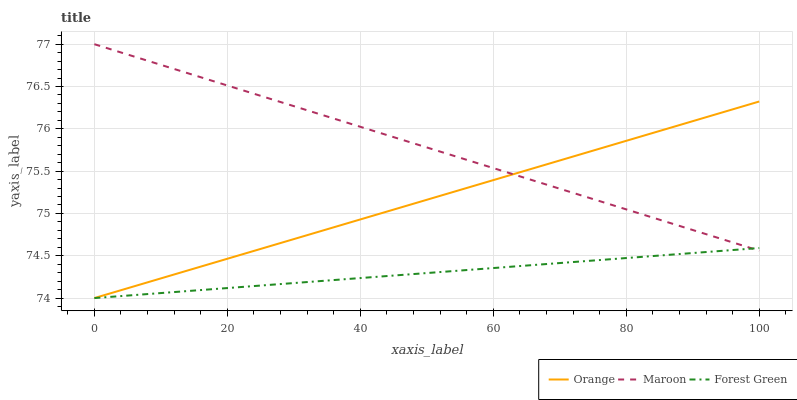Does Forest Green have the minimum area under the curve?
Answer yes or no. Yes. Does Maroon have the maximum area under the curve?
Answer yes or no. Yes. Does Maroon have the minimum area under the curve?
Answer yes or no. No. Does Forest Green have the maximum area under the curve?
Answer yes or no. No. Is Forest Green the smoothest?
Answer yes or no. Yes. Is Orange the roughest?
Answer yes or no. Yes. Is Maroon the smoothest?
Answer yes or no. No. Is Maroon the roughest?
Answer yes or no. No. Does Orange have the lowest value?
Answer yes or no. Yes. Does Maroon have the lowest value?
Answer yes or no. No. Does Maroon have the highest value?
Answer yes or no. Yes. Does Forest Green have the highest value?
Answer yes or no. No. Does Forest Green intersect Orange?
Answer yes or no. Yes. Is Forest Green less than Orange?
Answer yes or no. No. Is Forest Green greater than Orange?
Answer yes or no. No. 